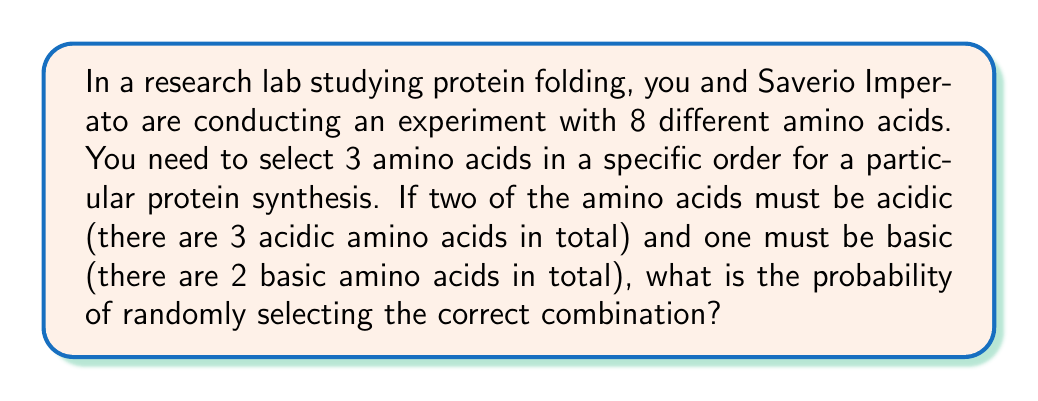Could you help me with this problem? Let's approach this step-by-step:

1) First, we need to calculate the total number of ways to select 3 amino acids from 8:
   $$\text{Total combinations} = 8 \times 7 \times 6 = 336$$

2) Now, let's calculate the number of favorable outcomes:
   a) We need to select 2 acidic amino acids out of 3, and 1 basic amino acid out of 2.
   b) We also need to consider the order of selection.

3) Calculate the number of ways to select 2 acidic amino acids:
   $$\binom{3}{2} = 3$$

4) There are 2! = 2 ways to arrange these 2 acidic amino acids.

5) There are 2 ways to select 1 basic amino acid out of 2.

6) The favorable outcomes can be arranged in 3 ways:
   (Acidic, Acidic, Basic), (Acidic, Basic, Acidic), (Basic, Acidic, Acidic)

7) Therefore, the total number of favorable outcomes is:
   $$3 \times 2 \times 2 \times 3 = 36$$

8) The probability is the number of favorable outcomes divided by the total number of possible outcomes:
   $$P = \frac{36}{336} = \frac{3}{28} \approx 0.1071$$
Answer: $\frac{3}{28}$ 